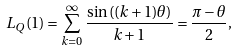Convert formula to latex. <formula><loc_0><loc_0><loc_500><loc_500>L _ { Q } ( 1 ) = \sum _ { k = 0 } ^ { \infty } \frac { \sin \left ( ( k + 1 ) \theta \right ) } { k + 1 } = \frac { \pi - \theta } { 2 } ,</formula> 